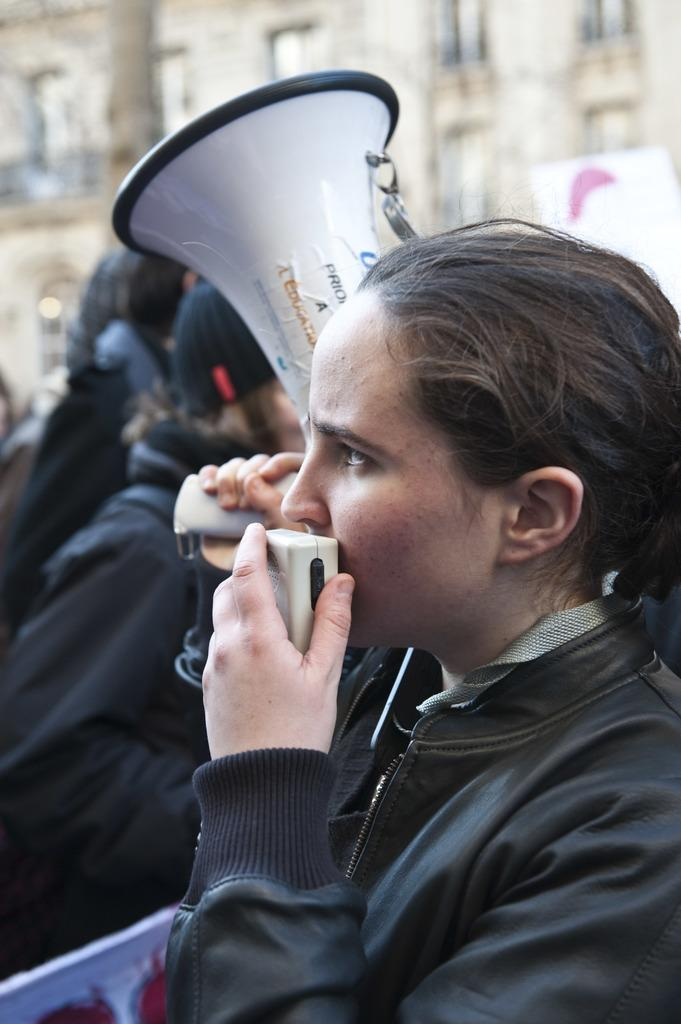What is the main subject of the image? There is a woman in the image. What is the woman holding in the image? The woman is holding an object. Can you describe another object in the image? There is a megaphone in the image. Are there any other people present in the image? Yes, there are other people present in the image. What can be seen in the background of the image? There is a building in the background of the image. What type of beggar can be seen laughing in the image? There is no beggar or laughter present in the image. 